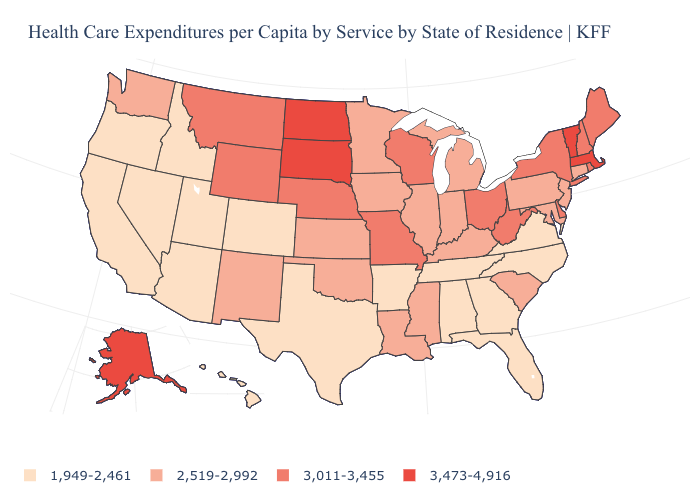What is the highest value in the West ?
Give a very brief answer. 3,473-4,916. Name the states that have a value in the range 2,519-2,992?
Answer briefly. Connecticut, Illinois, Indiana, Iowa, Kansas, Kentucky, Louisiana, Maryland, Michigan, Minnesota, Mississippi, New Jersey, New Mexico, Oklahoma, Pennsylvania, South Carolina, Washington. Does Maryland have a lower value than Delaware?
Write a very short answer. Yes. What is the value of Washington?
Concise answer only. 2,519-2,992. Which states hav the highest value in the MidWest?
Quick response, please. North Dakota, South Dakota. What is the lowest value in the West?
Write a very short answer. 1,949-2,461. Among the states that border North Carolina , does Virginia have the highest value?
Give a very brief answer. No. Which states have the highest value in the USA?
Be succinct. Alaska, Massachusetts, North Dakota, South Dakota, Vermont. Name the states that have a value in the range 3,473-4,916?
Give a very brief answer. Alaska, Massachusetts, North Dakota, South Dakota, Vermont. Name the states that have a value in the range 3,011-3,455?
Quick response, please. Delaware, Maine, Missouri, Montana, Nebraska, New Hampshire, New York, Ohio, Rhode Island, West Virginia, Wisconsin, Wyoming. Which states hav the highest value in the MidWest?
Answer briefly. North Dakota, South Dakota. Among the states that border Indiana , does Ohio have the highest value?
Concise answer only. Yes. What is the value of Wisconsin?
Give a very brief answer. 3,011-3,455. Does Montana have a higher value than Vermont?
Short answer required. No. Name the states that have a value in the range 3,011-3,455?
Answer briefly. Delaware, Maine, Missouri, Montana, Nebraska, New Hampshire, New York, Ohio, Rhode Island, West Virginia, Wisconsin, Wyoming. 